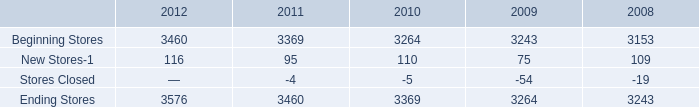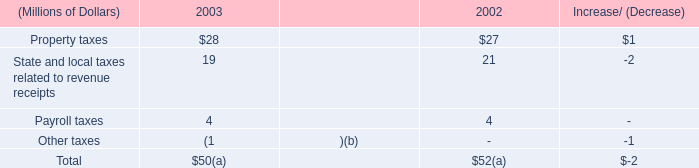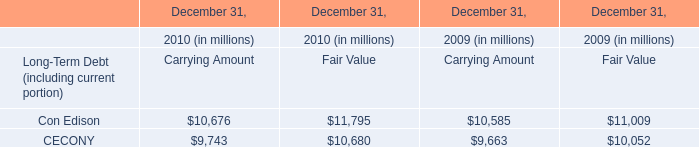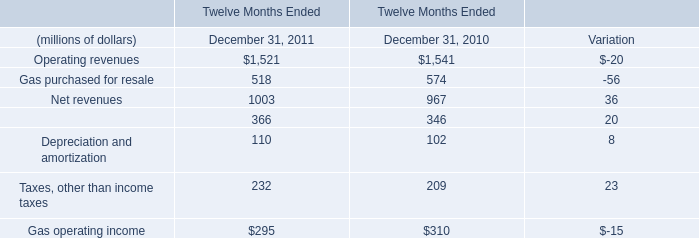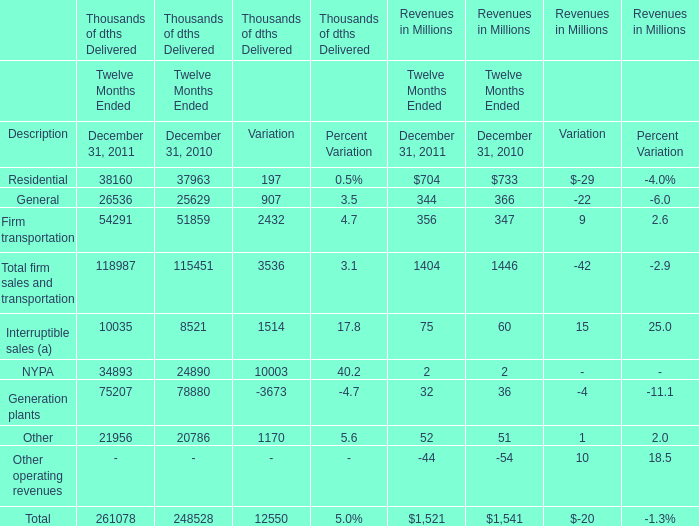what is the growth rate in the number of stores during 2012? 
Computations: ((3576 - 3460) / 3460)
Answer: 0.03353. 